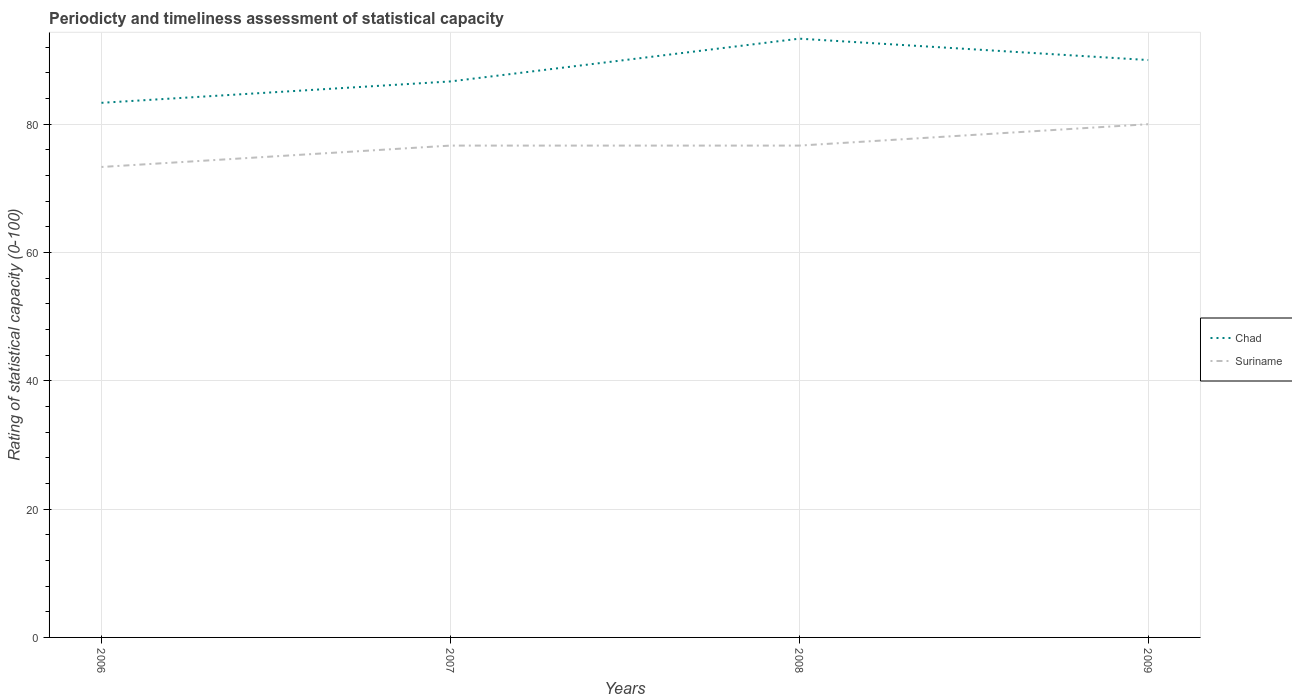Does the line corresponding to Chad intersect with the line corresponding to Suriname?
Offer a very short reply. No. Is the number of lines equal to the number of legend labels?
Ensure brevity in your answer.  Yes. Across all years, what is the maximum rating of statistical capacity in Suriname?
Provide a succinct answer. 73.33. In which year was the rating of statistical capacity in Chad maximum?
Your answer should be very brief. 2006. What is the total rating of statistical capacity in Suriname in the graph?
Offer a very short reply. -3.33. What is the difference between the highest and the second highest rating of statistical capacity in Suriname?
Give a very brief answer. 6.67. What is the difference between the highest and the lowest rating of statistical capacity in Suriname?
Offer a very short reply. 3. Is the rating of statistical capacity in Suriname strictly greater than the rating of statistical capacity in Chad over the years?
Your answer should be compact. Yes. How many lines are there?
Keep it short and to the point. 2. What is the difference between two consecutive major ticks on the Y-axis?
Provide a short and direct response. 20. Are the values on the major ticks of Y-axis written in scientific E-notation?
Keep it short and to the point. No. Does the graph contain grids?
Your answer should be compact. Yes. Where does the legend appear in the graph?
Make the answer very short. Center right. How are the legend labels stacked?
Offer a very short reply. Vertical. What is the title of the graph?
Make the answer very short. Periodicty and timeliness assessment of statistical capacity. What is the label or title of the X-axis?
Offer a terse response. Years. What is the label or title of the Y-axis?
Your answer should be compact. Rating of statistical capacity (0-100). What is the Rating of statistical capacity (0-100) of Chad in 2006?
Provide a succinct answer. 83.33. What is the Rating of statistical capacity (0-100) of Suriname in 2006?
Offer a very short reply. 73.33. What is the Rating of statistical capacity (0-100) of Chad in 2007?
Provide a short and direct response. 86.67. What is the Rating of statistical capacity (0-100) of Suriname in 2007?
Your answer should be very brief. 76.67. What is the Rating of statistical capacity (0-100) of Chad in 2008?
Ensure brevity in your answer.  93.33. What is the Rating of statistical capacity (0-100) of Suriname in 2008?
Keep it short and to the point. 76.67. What is the Rating of statistical capacity (0-100) in Chad in 2009?
Provide a short and direct response. 90. What is the Rating of statistical capacity (0-100) of Suriname in 2009?
Your response must be concise. 80. Across all years, what is the maximum Rating of statistical capacity (0-100) of Chad?
Offer a very short reply. 93.33. Across all years, what is the minimum Rating of statistical capacity (0-100) of Chad?
Provide a succinct answer. 83.33. Across all years, what is the minimum Rating of statistical capacity (0-100) in Suriname?
Keep it short and to the point. 73.33. What is the total Rating of statistical capacity (0-100) of Chad in the graph?
Give a very brief answer. 353.33. What is the total Rating of statistical capacity (0-100) in Suriname in the graph?
Offer a very short reply. 306.67. What is the difference between the Rating of statistical capacity (0-100) in Chad in 2006 and that in 2007?
Keep it short and to the point. -3.33. What is the difference between the Rating of statistical capacity (0-100) in Chad in 2006 and that in 2009?
Keep it short and to the point. -6.67. What is the difference between the Rating of statistical capacity (0-100) of Suriname in 2006 and that in 2009?
Offer a very short reply. -6.67. What is the difference between the Rating of statistical capacity (0-100) in Chad in 2007 and that in 2008?
Your answer should be very brief. -6.67. What is the difference between the Rating of statistical capacity (0-100) of Suriname in 2008 and that in 2009?
Provide a short and direct response. -3.33. What is the difference between the Rating of statistical capacity (0-100) of Chad in 2006 and the Rating of statistical capacity (0-100) of Suriname in 2007?
Make the answer very short. 6.67. What is the difference between the Rating of statistical capacity (0-100) of Chad in 2008 and the Rating of statistical capacity (0-100) of Suriname in 2009?
Your answer should be very brief. 13.33. What is the average Rating of statistical capacity (0-100) of Chad per year?
Provide a succinct answer. 88.33. What is the average Rating of statistical capacity (0-100) in Suriname per year?
Keep it short and to the point. 76.67. In the year 2008, what is the difference between the Rating of statistical capacity (0-100) in Chad and Rating of statistical capacity (0-100) in Suriname?
Offer a very short reply. 16.67. What is the ratio of the Rating of statistical capacity (0-100) of Chad in 2006 to that in 2007?
Offer a terse response. 0.96. What is the ratio of the Rating of statistical capacity (0-100) of Suriname in 2006 to that in 2007?
Ensure brevity in your answer.  0.96. What is the ratio of the Rating of statistical capacity (0-100) in Chad in 2006 to that in 2008?
Make the answer very short. 0.89. What is the ratio of the Rating of statistical capacity (0-100) in Suriname in 2006 to that in 2008?
Provide a succinct answer. 0.96. What is the ratio of the Rating of statistical capacity (0-100) in Chad in 2006 to that in 2009?
Offer a very short reply. 0.93. What is the ratio of the Rating of statistical capacity (0-100) of Suriname in 2006 to that in 2009?
Offer a very short reply. 0.92. What is the ratio of the Rating of statistical capacity (0-100) of Chad in 2007 to that in 2008?
Provide a short and direct response. 0.93. What is the ratio of the Rating of statistical capacity (0-100) of Chad in 2007 to that in 2009?
Your answer should be compact. 0.96. What is the ratio of the Rating of statistical capacity (0-100) of Suriname in 2008 to that in 2009?
Keep it short and to the point. 0.96. What is the difference between the highest and the second highest Rating of statistical capacity (0-100) in Suriname?
Ensure brevity in your answer.  3.33. 